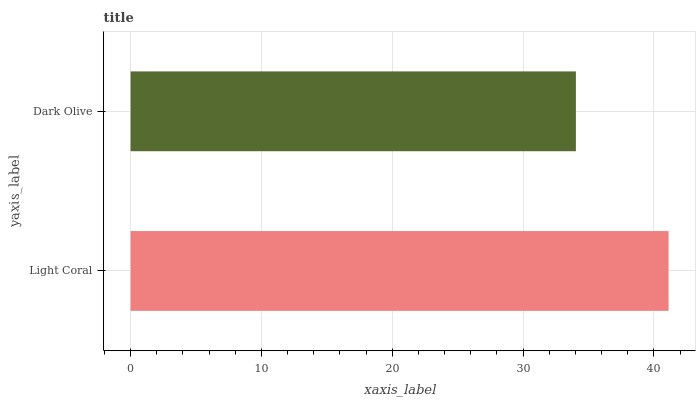Is Dark Olive the minimum?
Answer yes or no. Yes. Is Light Coral the maximum?
Answer yes or no. Yes. Is Dark Olive the maximum?
Answer yes or no. No. Is Light Coral greater than Dark Olive?
Answer yes or no. Yes. Is Dark Olive less than Light Coral?
Answer yes or no. Yes. Is Dark Olive greater than Light Coral?
Answer yes or no. No. Is Light Coral less than Dark Olive?
Answer yes or no. No. Is Light Coral the high median?
Answer yes or no. Yes. Is Dark Olive the low median?
Answer yes or no. Yes. Is Dark Olive the high median?
Answer yes or no. No. Is Light Coral the low median?
Answer yes or no. No. 